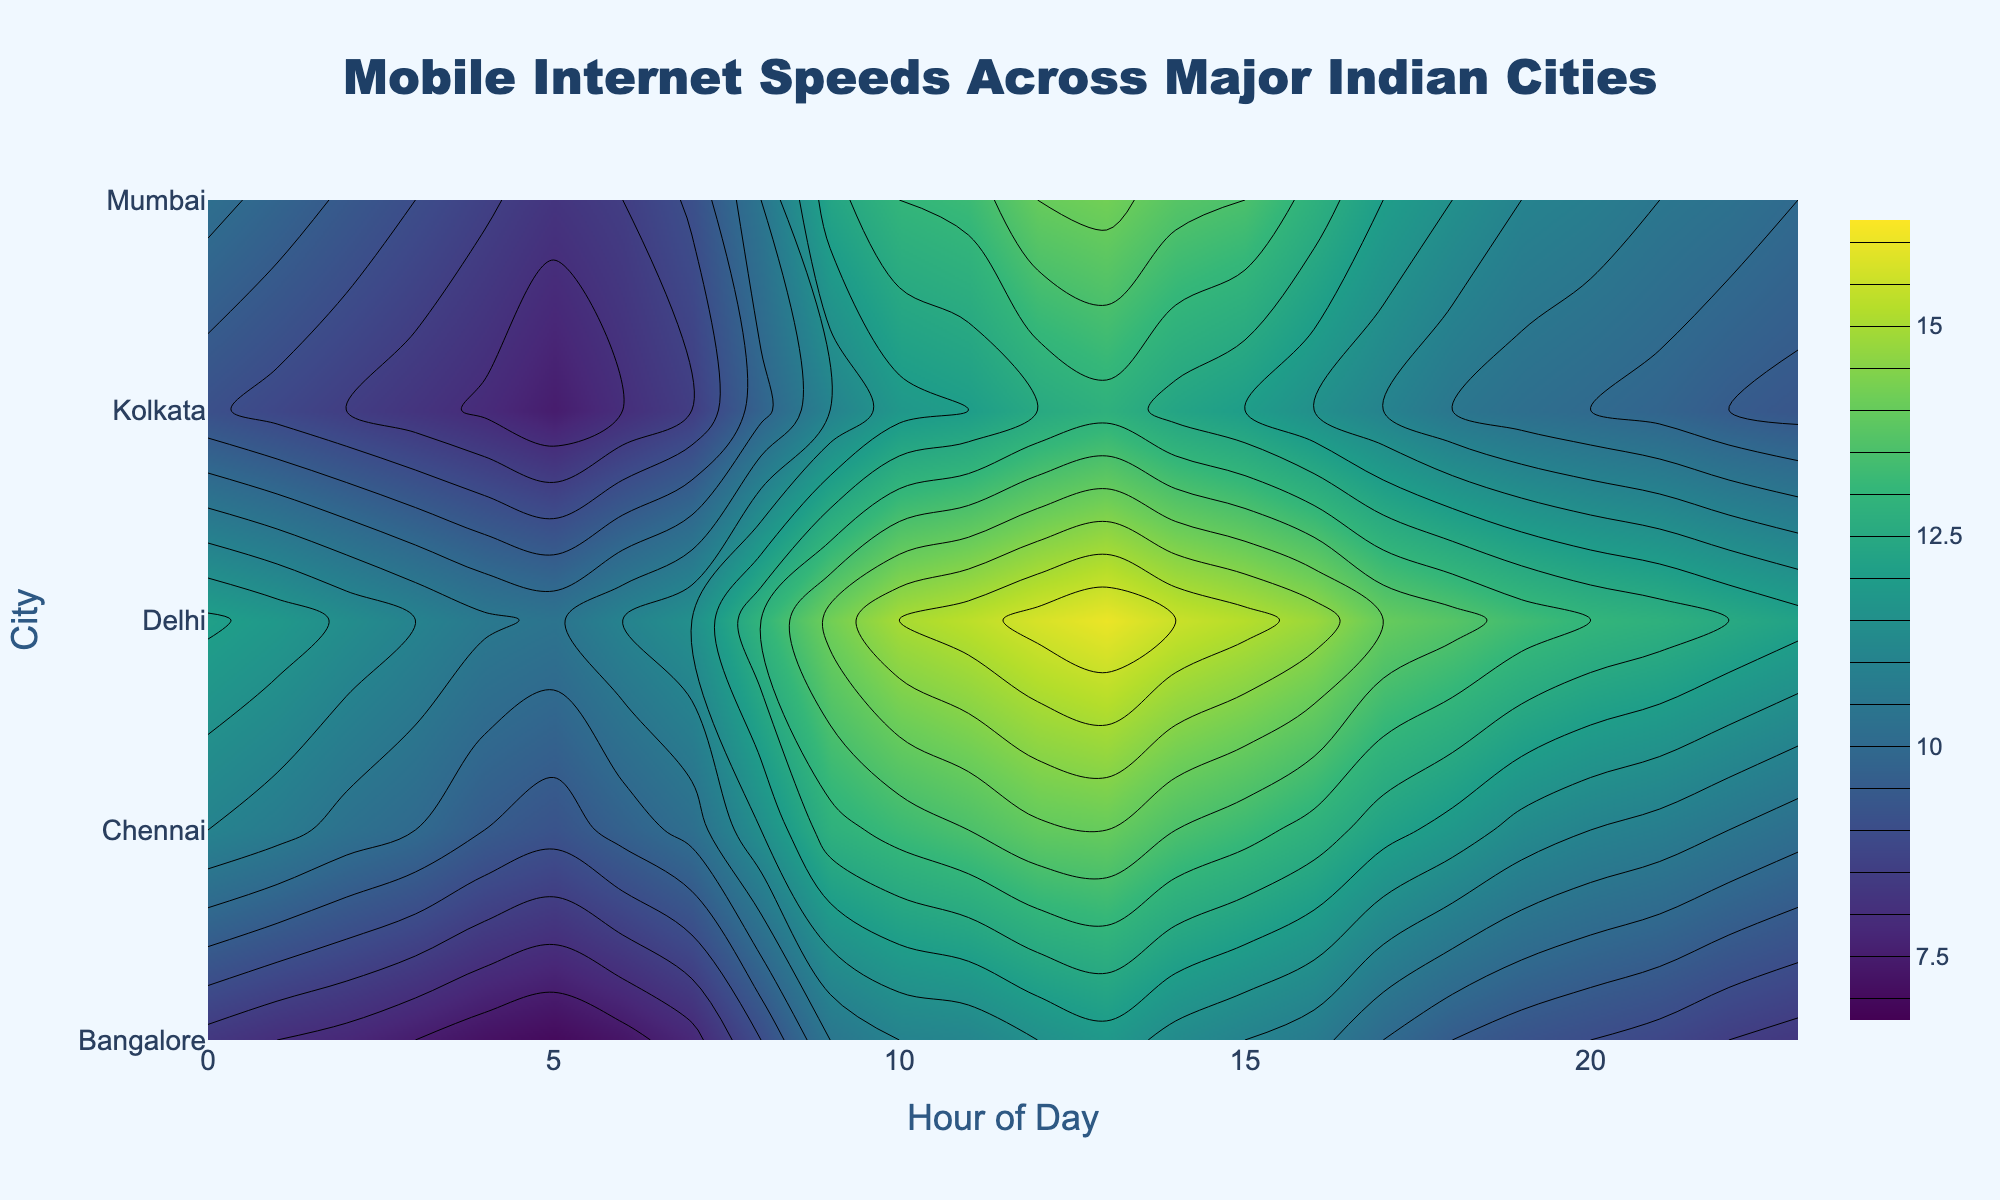What is the title of the contour plot? The title is typically written at the top of the plot and provides a brief description of what the plot represents. Here, it states the subject of the plot: "Mobile Internet Speeds Across Major Indian Cities".
Answer: Mobile Internet Speeds Across Major Indian Cities What are the axes labels in the contour plot? The x-axis and y-axis labels describe what each axis represents. The x-axis label here is "Hour of Day" indicating different hours, and the y-axis label is "City" indicating different cities.
Answer: Hour of Day, City Which city has the highest mobile internet speed at noon (12 PM)? To find this, locate the 12 PM column in the plot and check for the highest value on the corresponding row for each city. According to the data, Delhi has the highest speed at 15.7 Mbps.
Answer: Delhi At which hour does Mumbai experience the lowest internet speed, and what is that speed? Locate the values in the rows corresponding to Mumbai and identify the minimum value and its corresponding hour. The lowest speed for Mumbai is 8.2 Mbps at 5 AM.
Answer: 5 AM, 8.2 Mbps How does the internet speed in Bangalore at 10 AM compare to the speed in Kolkata at the same time? Find the values for Bangalore and Kolkata at 10 AM and compare them. Bangalore's speed is 11.0 Mbps, while Kolkata's speed is 11.8 Mbps at 10 AM. Kolkata's speed is higher.
Answer: Kolkata's speed is higher What is the average mobile internet speed in Chennai across all hours of the day? Sum all the speeds for Chennai across 24 hours and divide by 24. Adding up all the speeds: 11.0+10.7+10.3+10.0+9.5+9.2+9.7+10.2+11.5+12.8+13.2+13.5+13.9+14.0+13.5+13.2+12.8+12.2+11.8+11.3+11.0+10.8+10.5+10.2 = 287.8. Then, the average is 287.8/24.
Answer: 11.99 Mbps What is the most significant increase in internet speed observed in any city within an hour? Check for the maximum difference between consecutive hours for all cities. For Delhi, from 7 AM to 8 AM, the speed increases from 11.5 to 13.0 Mbps. The increase of 1.5 Mbps is the most significant within a single hour.
Answer: 1.5 Mbps, Delhi, 7 AM to 8 AM Which hour generally shows peak internet speeds across all cities? Observe the contour plot for the hour that consistently shows higher speed values across multiple cities. The hours around noon, particularly between 12 PM to 2 PM, seem to have the highest speeds across most cities.
Answer: Around noon (12 PM to 2 PM) Is there any city where the internet speed remains relatively consistent throughout the day? Analyze the contour plot for a city with less variation in speeds across hours. Kolkata shows relatively consistent speeds with slight variations throughout the day.
Answer: Kolkata 